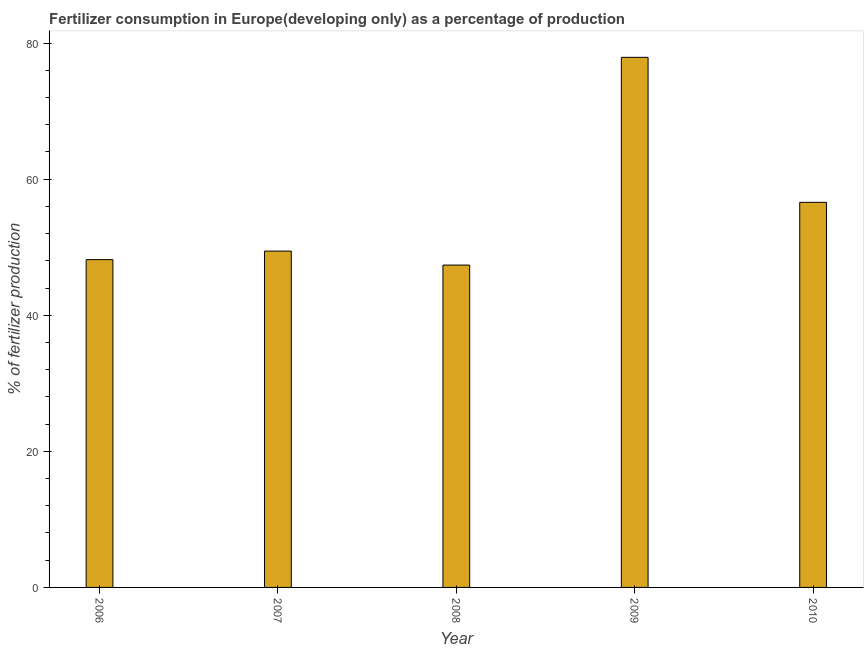Does the graph contain grids?
Keep it short and to the point. No. What is the title of the graph?
Offer a terse response. Fertilizer consumption in Europe(developing only) as a percentage of production. What is the label or title of the X-axis?
Provide a short and direct response. Year. What is the label or title of the Y-axis?
Your answer should be compact. % of fertilizer production. What is the amount of fertilizer consumption in 2009?
Make the answer very short. 77.91. Across all years, what is the maximum amount of fertilizer consumption?
Provide a short and direct response. 77.91. Across all years, what is the minimum amount of fertilizer consumption?
Your answer should be compact. 47.38. In which year was the amount of fertilizer consumption maximum?
Ensure brevity in your answer.  2009. In which year was the amount of fertilizer consumption minimum?
Make the answer very short. 2008. What is the sum of the amount of fertilizer consumption?
Your answer should be compact. 279.51. What is the difference between the amount of fertilizer consumption in 2006 and 2010?
Ensure brevity in your answer.  -8.42. What is the average amount of fertilizer consumption per year?
Give a very brief answer. 55.9. What is the median amount of fertilizer consumption?
Ensure brevity in your answer.  49.43. In how many years, is the amount of fertilizer consumption greater than 16 %?
Offer a very short reply. 5. Do a majority of the years between 2006 and 2010 (inclusive) have amount of fertilizer consumption greater than 44 %?
Offer a terse response. Yes. What is the ratio of the amount of fertilizer consumption in 2009 to that in 2010?
Your response must be concise. 1.38. Is the amount of fertilizer consumption in 2007 less than that in 2008?
Your answer should be very brief. No. Is the difference between the amount of fertilizer consumption in 2006 and 2008 greater than the difference between any two years?
Offer a very short reply. No. What is the difference between the highest and the second highest amount of fertilizer consumption?
Provide a short and direct response. 21.31. Is the sum of the amount of fertilizer consumption in 2007 and 2009 greater than the maximum amount of fertilizer consumption across all years?
Offer a very short reply. Yes. What is the difference between the highest and the lowest amount of fertilizer consumption?
Provide a succinct answer. 30.53. In how many years, is the amount of fertilizer consumption greater than the average amount of fertilizer consumption taken over all years?
Provide a succinct answer. 2. How many years are there in the graph?
Offer a very short reply. 5. What is the difference between two consecutive major ticks on the Y-axis?
Your answer should be compact. 20. Are the values on the major ticks of Y-axis written in scientific E-notation?
Your response must be concise. No. What is the % of fertilizer production of 2006?
Your response must be concise. 48.18. What is the % of fertilizer production in 2007?
Your answer should be very brief. 49.43. What is the % of fertilizer production of 2008?
Provide a succinct answer. 47.38. What is the % of fertilizer production of 2009?
Your answer should be compact. 77.91. What is the % of fertilizer production in 2010?
Offer a very short reply. 56.6. What is the difference between the % of fertilizer production in 2006 and 2007?
Your answer should be very brief. -1.25. What is the difference between the % of fertilizer production in 2006 and 2008?
Your response must be concise. 0.8. What is the difference between the % of fertilizer production in 2006 and 2009?
Your response must be concise. -29.74. What is the difference between the % of fertilizer production in 2006 and 2010?
Provide a succinct answer. -8.42. What is the difference between the % of fertilizer production in 2007 and 2008?
Your answer should be very brief. 2.05. What is the difference between the % of fertilizer production in 2007 and 2009?
Your answer should be compact. -28.48. What is the difference between the % of fertilizer production in 2007 and 2010?
Keep it short and to the point. -7.17. What is the difference between the % of fertilizer production in 2008 and 2009?
Provide a succinct answer. -30.53. What is the difference between the % of fertilizer production in 2008 and 2010?
Offer a terse response. -9.22. What is the difference between the % of fertilizer production in 2009 and 2010?
Your response must be concise. 21.31. What is the ratio of the % of fertilizer production in 2006 to that in 2007?
Make the answer very short. 0.97. What is the ratio of the % of fertilizer production in 2006 to that in 2009?
Ensure brevity in your answer.  0.62. What is the ratio of the % of fertilizer production in 2006 to that in 2010?
Provide a succinct answer. 0.85. What is the ratio of the % of fertilizer production in 2007 to that in 2008?
Your answer should be very brief. 1.04. What is the ratio of the % of fertilizer production in 2007 to that in 2009?
Give a very brief answer. 0.63. What is the ratio of the % of fertilizer production in 2007 to that in 2010?
Keep it short and to the point. 0.87. What is the ratio of the % of fertilizer production in 2008 to that in 2009?
Keep it short and to the point. 0.61. What is the ratio of the % of fertilizer production in 2008 to that in 2010?
Ensure brevity in your answer.  0.84. What is the ratio of the % of fertilizer production in 2009 to that in 2010?
Offer a terse response. 1.38. 